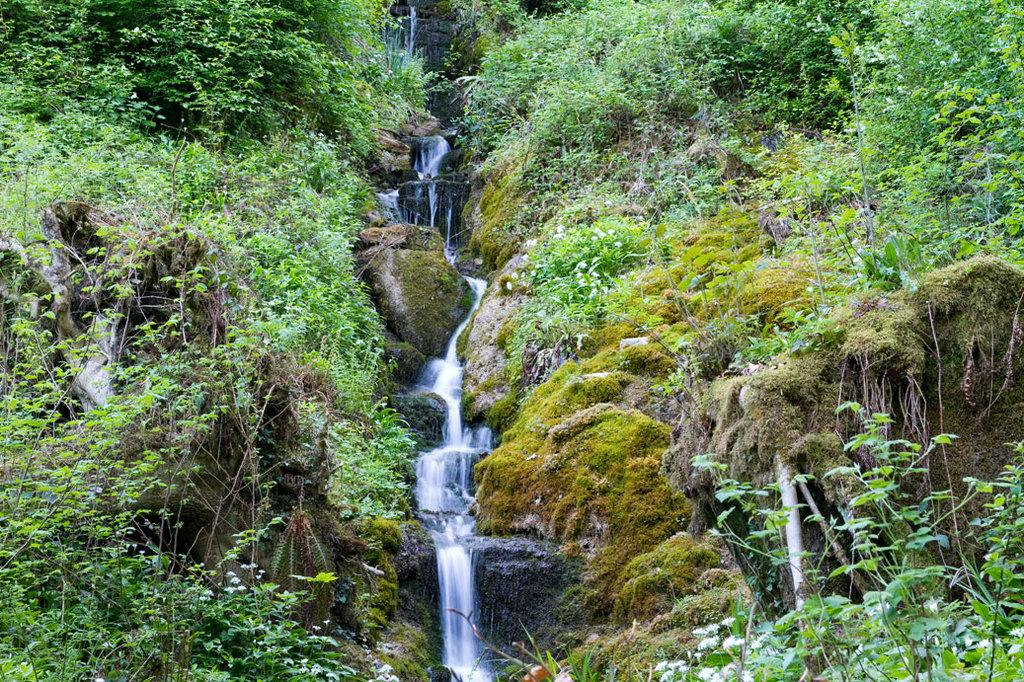What type of plants can be seen in the image? There are green color plants in the image. What is happening with the water in the image? There is water flowing in the image. Can you hear the cactus whistling and laughing in the image? There is no cactus, whistling, or laughing present in the image. 